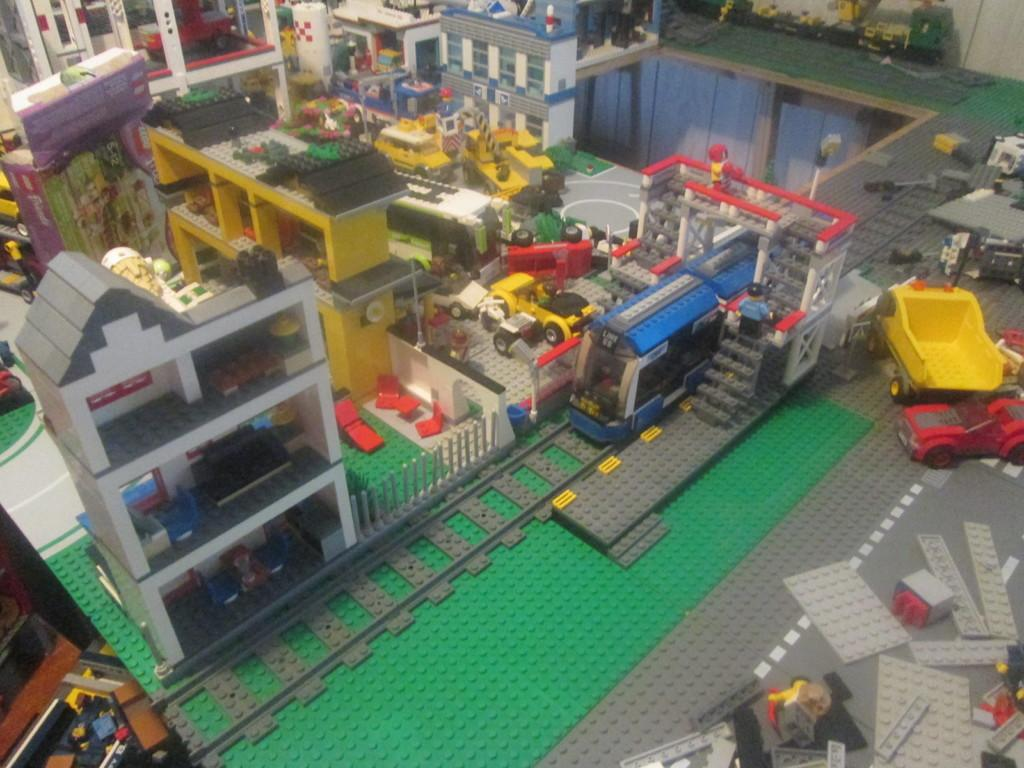What type of toys are present in the image? There are toy buildings, toy vehicles, toy persons, toy trees, toy road, toy wall, toy steps, and toy boards in the image. What is the setting for the toys in the image? The image may have been taken in a hall. What is the grass in the image made of? The grass in the image is made up of building blocks. Where is the drawer located in the image? There is no drawer present in the image. What type of badge is being worn by the toy person in the image? There are no badges or toy persons wearing badges in the image. 